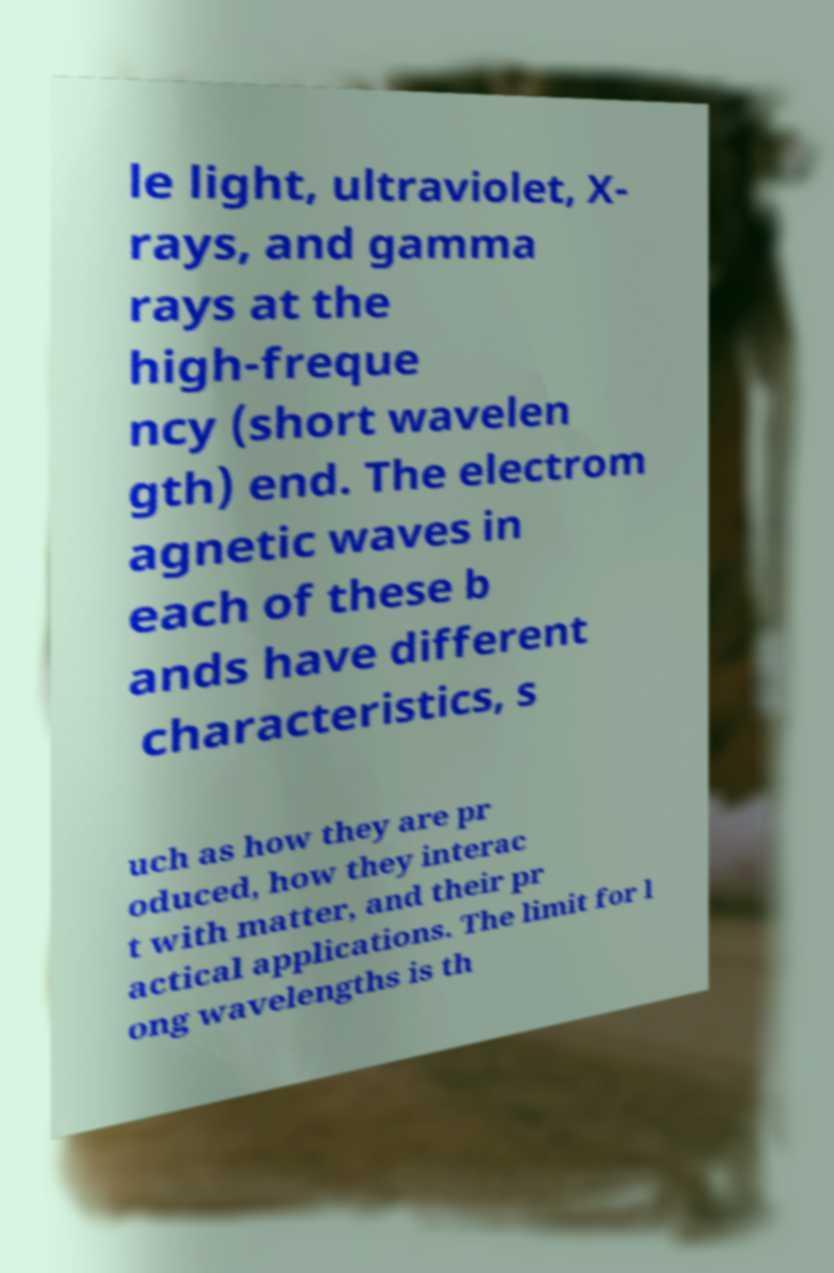What messages or text are displayed in this image? I need them in a readable, typed format. le light, ultraviolet, X- rays, and gamma rays at the high-freque ncy (short wavelen gth) end. The electrom agnetic waves in each of these b ands have different characteristics, s uch as how they are pr oduced, how they interac t with matter, and their pr actical applications. The limit for l ong wavelengths is th 